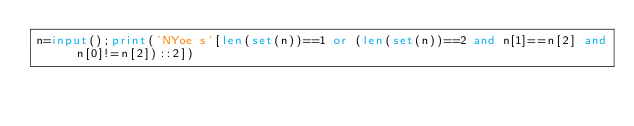<code> <loc_0><loc_0><loc_500><loc_500><_Python_>n=input();print('NYoe s'[len(set(n))==1 or (len(set(n))==2 and n[1]==n[2] and n[0]!=n[2])::2])</code> 